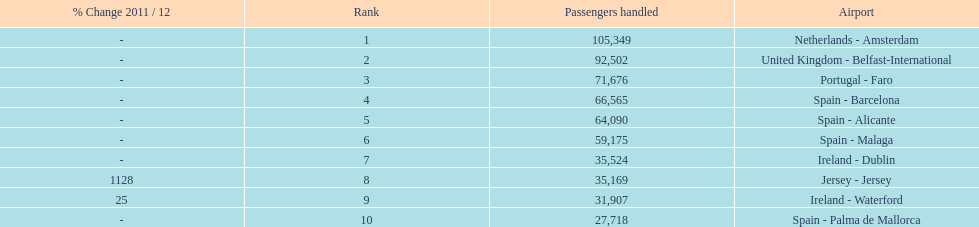What is the count of listed airports? 10. 